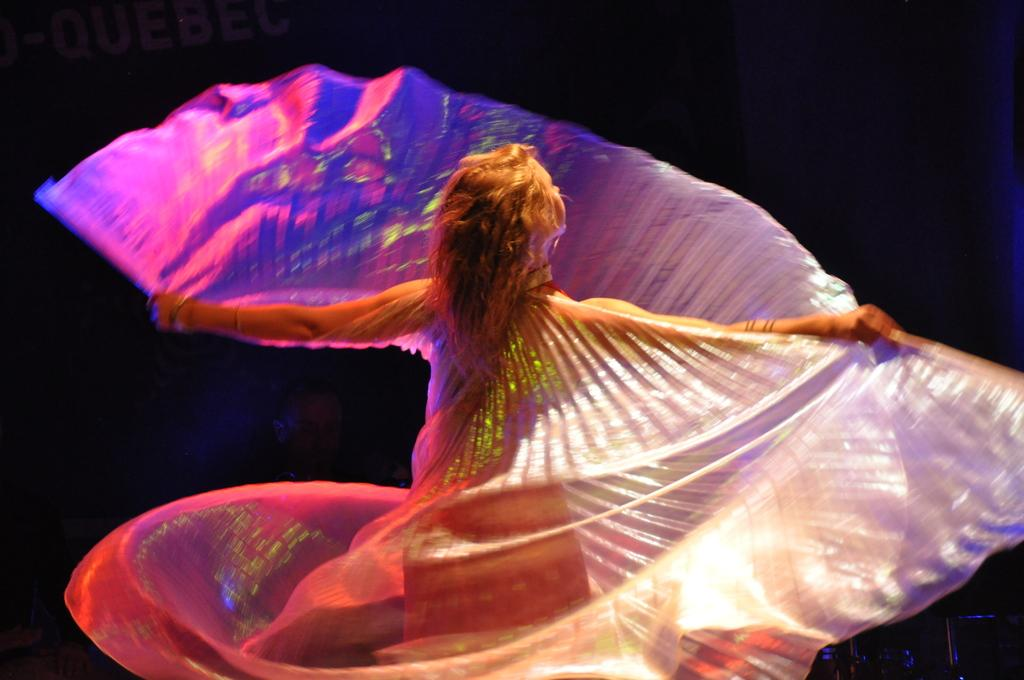Who is present in the image? There is a woman in the image. What is the woman wearing? The woman is wearing a colorful dress. What can be observed about the background of the image? The background of the image is dark. What type of silk is being spun by the woman in the image? There is no silk or spinning activity present in the image; the woman is simply wearing a colorful dress. How does the air affect the woman's appearance in the image? The air does not affect the woman's appearance in the image, as there is no indication of wind or movement. 